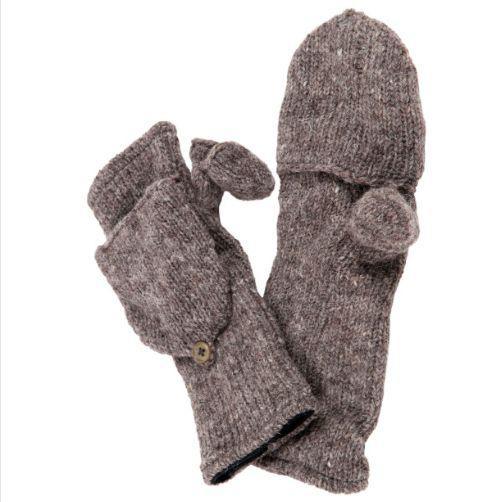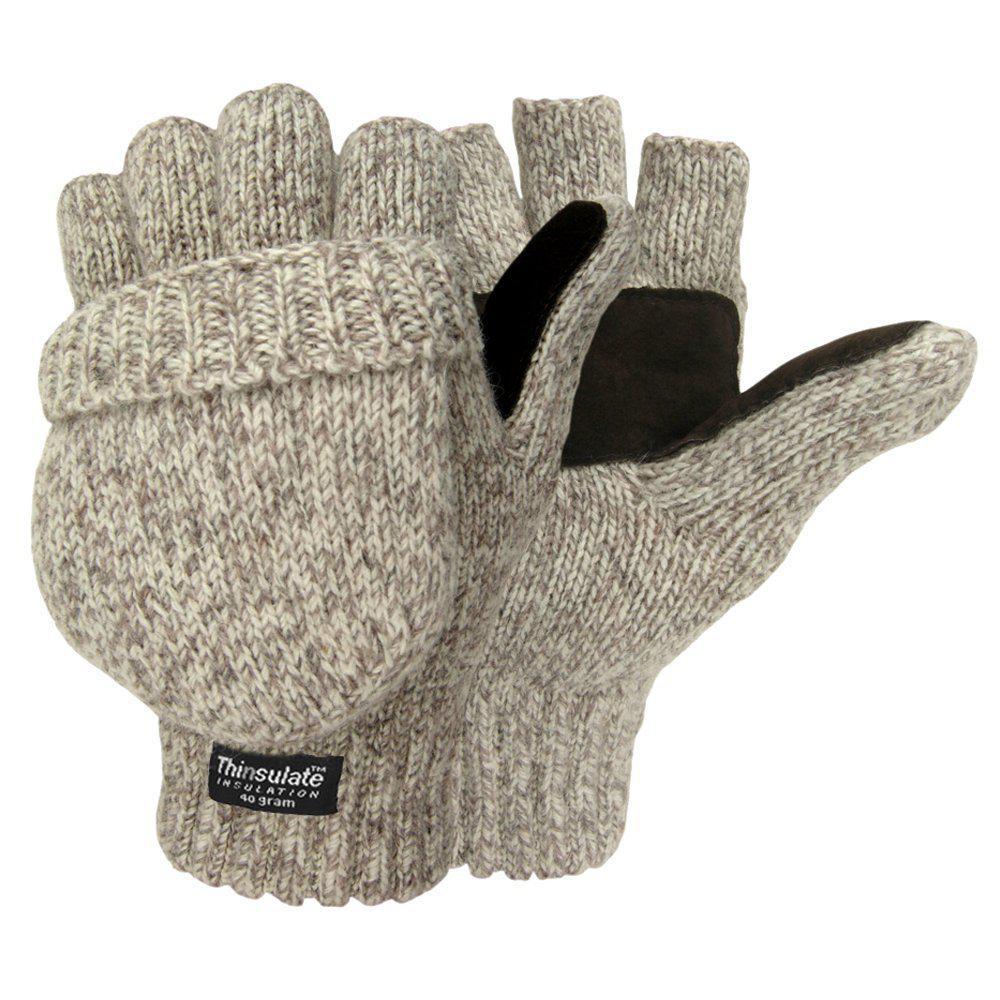The first image is the image on the left, the second image is the image on the right. Analyze the images presented: Is the assertion "A closed round mitten is faced palms down with the thumb part on the left side." valid? Answer yes or no. No. The first image is the image on the left, the second image is the image on the right. Examine the images to the left and right. Is the description "One pair of mittens is solid camel colored, and the other is heather colored with a dark brown patch." accurate? Answer yes or no. No. 